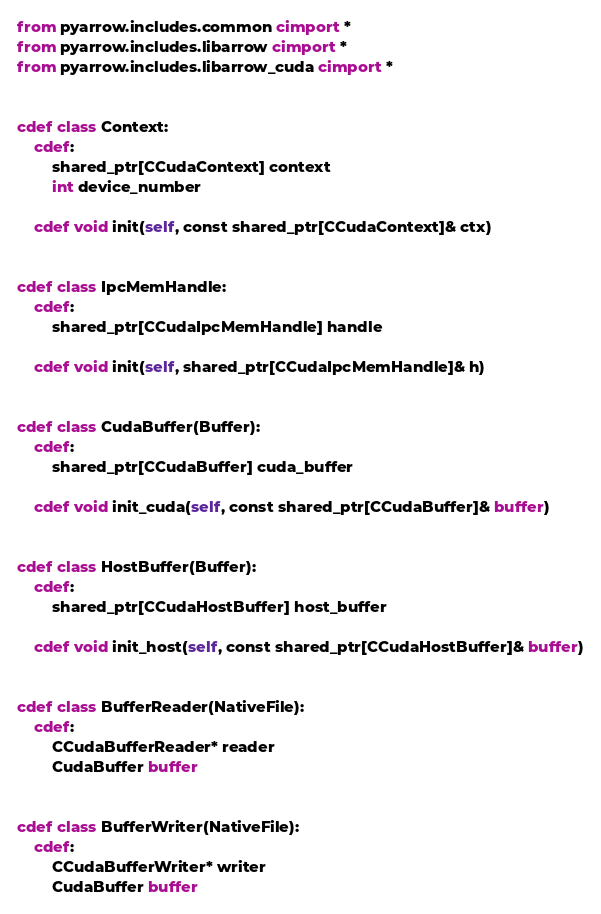Convert code to text. <code><loc_0><loc_0><loc_500><loc_500><_Cython_>from pyarrow.includes.common cimport *
from pyarrow.includes.libarrow cimport *
from pyarrow.includes.libarrow_cuda cimport *


cdef class Context:
    cdef:
        shared_ptr[CCudaContext] context
        int device_number

    cdef void init(self, const shared_ptr[CCudaContext]& ctx)


cdef class IpcMemHandle:
    cdef:
        shared_ptr[CCudaIpcMemHandle] handle

    cdef void init(self, shared_ptr[CCudaIpcMemHandle]& h)


cdef class CudaBuffer(Buffer):
    cdef:
        shared_ptr[CCudaBuffer] cuda_buffer

    cdef void init_cuda(self, const shared_ptr[CCudaBuffer]& buffer)


cdef class HostBuffer(Buffer):
    cdef:
        shared_ptr[CCudaHostBuffer] host_buffer

    cdef void init_host(self, const shared_ptr[CCudaHostBuffer]& buffer)


cdef class BufferReader(NativeFile):
    cdef:
        CCudaBufferReader* reader
        CudaBuffer buffer


cdef class BufferWriter(NativeFile):
    cdef:
        CCudaBufferWriter* writer
        CudaBuffer buffer
</code> 